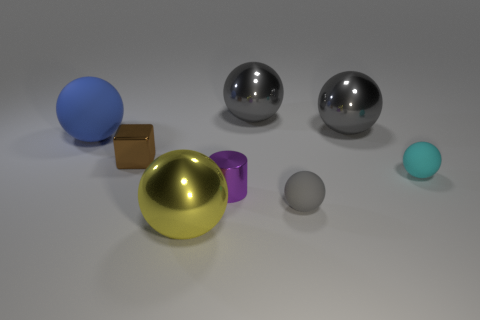Subtract all gray cylinders. How many gray balls are left? 3 Subtract 3 spheres. How many spheres are left? 3 Subtract all blue spheres. How many spheres are left? 5 Subtract all gray rubber spheres. How many spheres are left? 5 Subtract all blue balls. Subtract all gray cylinders. How many balls are left? 5 Add 2 small cyan matte cubes. How many objects exist? 10 Subtract all cylinders. How many objects are left? 7 Subtract 0 gray cylinders. How many objects are left? 8 Subtract all small cyan spheres. Subtract all tiny yellow metallic cylinders. How many objects are left? 7 Add 2 shiny objects. How many shiny objects are left? 7 